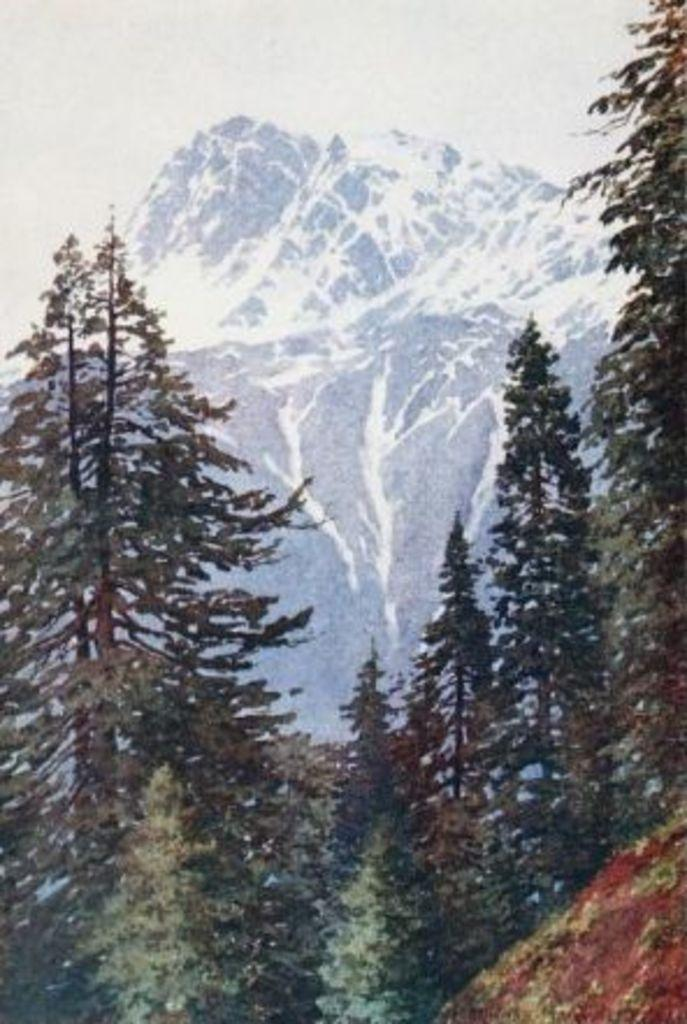What type of vegetation can be seen in the image? There are trees in the image. What is visible behind the trees in the image? The sky and mountains are visible behind the trees in the image. What rate of teaching is being conducted in the image? There is no teaching or educational context present in the image, so it is not possible to determine a rate of teaching. 